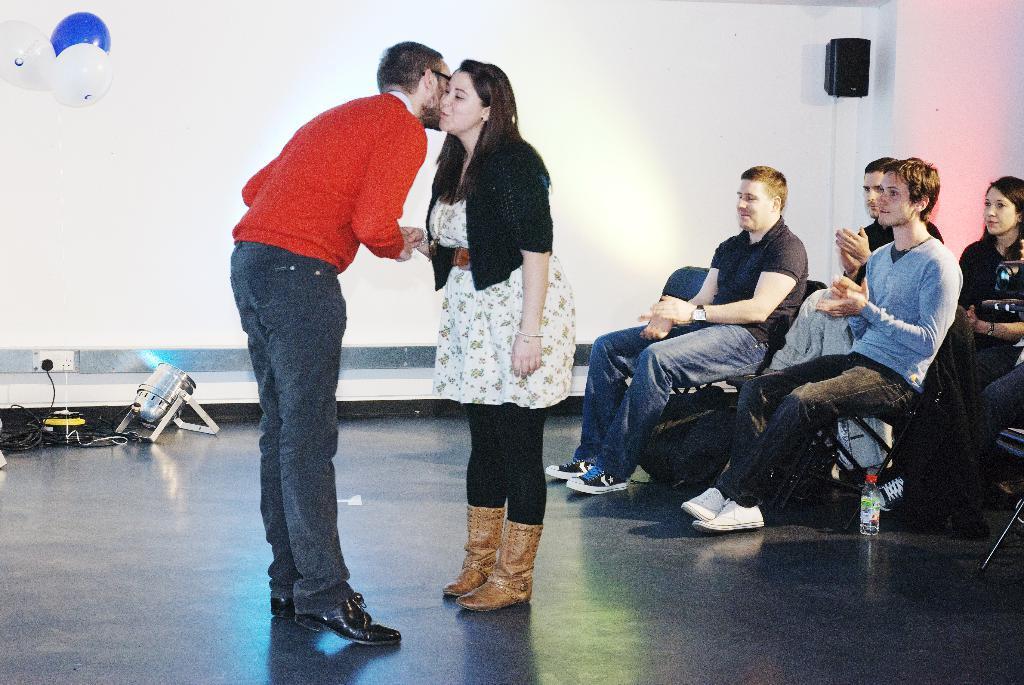Could you give a brief overview of what you see in this image? In the center of the image we can see a man and a woman shaking their hands standing on the floor. On the right side we can see a group of people sitting on the chairs. We can also see a bottle beside them. On the backside we can see some wires, a light. We can also see a speaker, balloons and a switch board on a wall. 